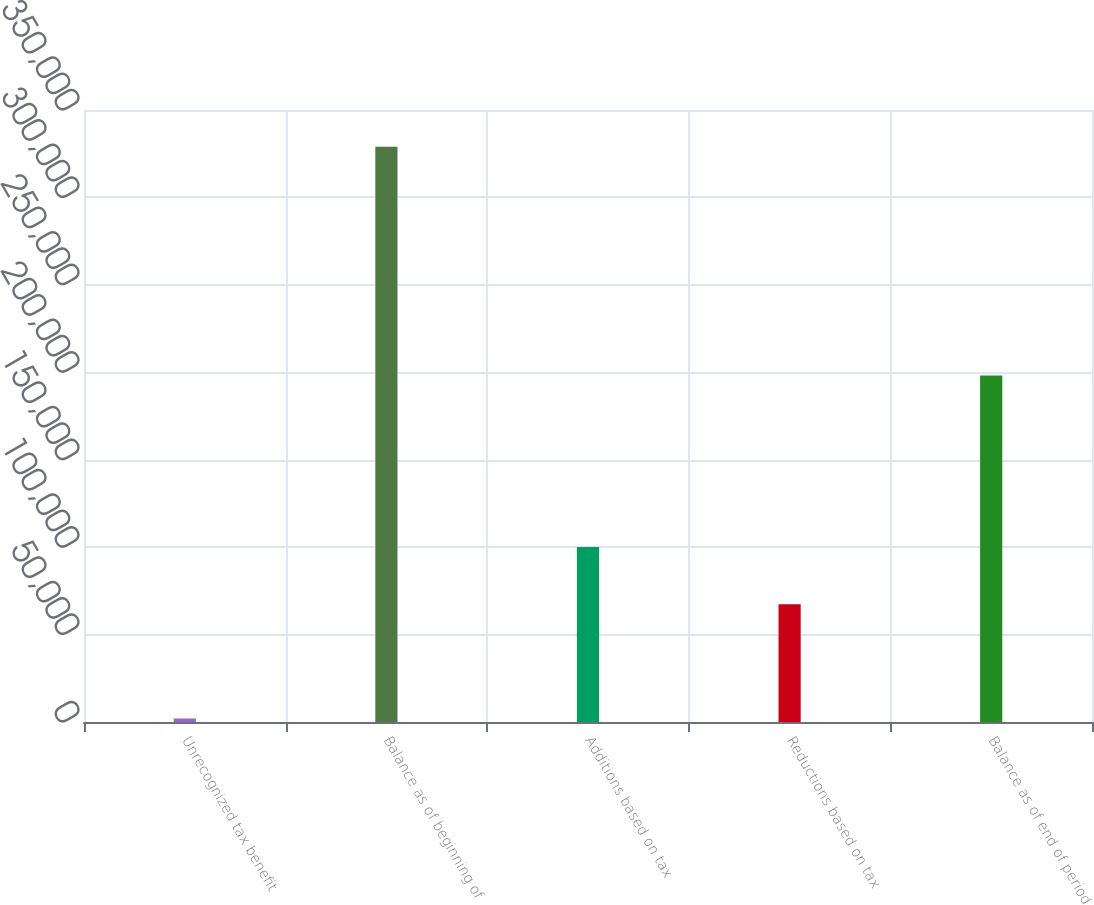Convert chart to OTSL. <chart><loc_0><loc_0><loc_500><loc_500><bar_chart><fcel>Unrecognized tax benefit<fcel>Balance as of beginning of<fcel>Additions based on tax<fcel>Reductions based on tax<fcel>Balance as of end of period<nl><fcel>2013<fcel>328951<fcel>100094<fcel>67400.6<fcel>198176<nl></chart> 